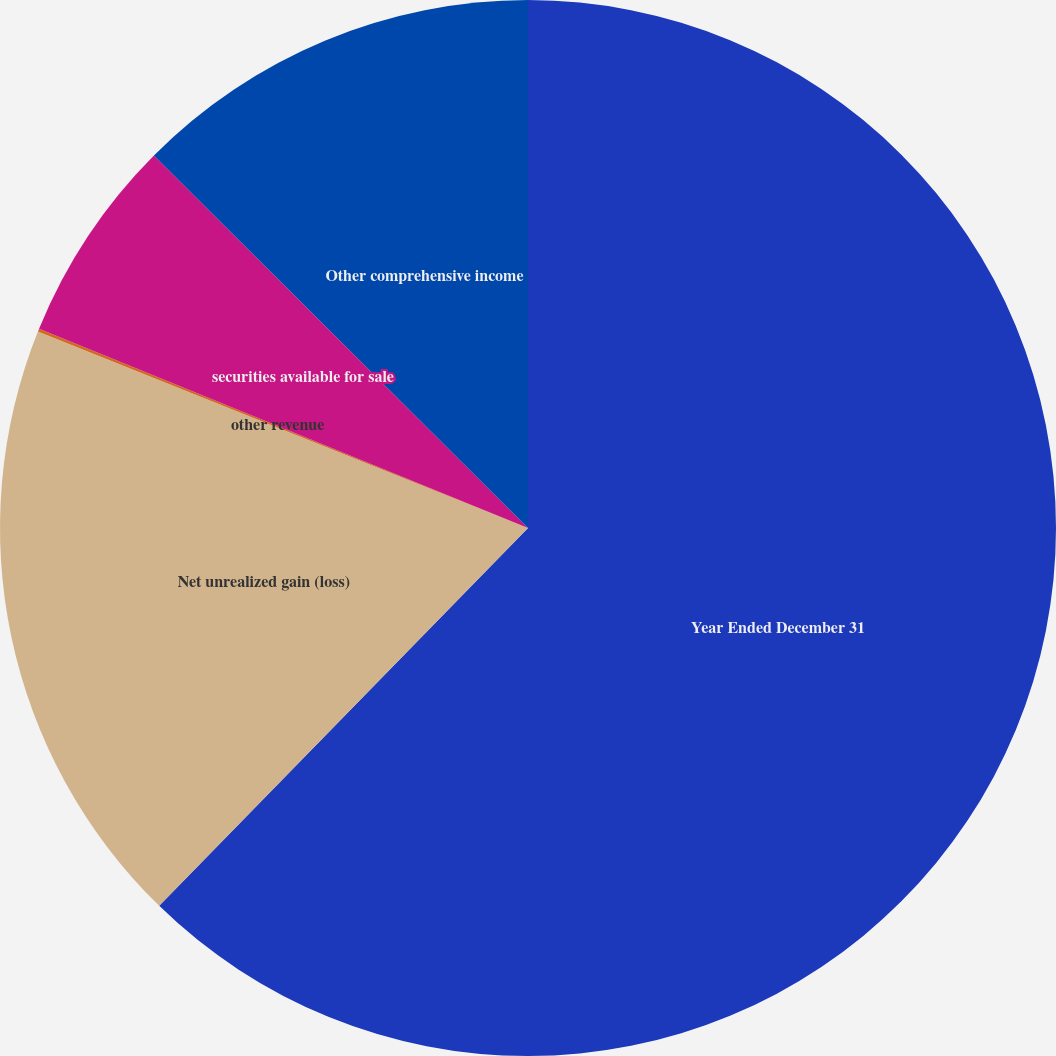<chart> <loc_0><loc_0><loc_500><loc_500><pie_chart><fcel>Year Ended December 31<fcel>Net unrealized gain (loss)<fcel>other revenue<fcel>securities available for sale<fcel>Other comprehensive income<nl><fcel>62.3%<fcel>18.76%<fcel>0.09%<fcel>6.31%<fcel>12.53%<nl></chart> 